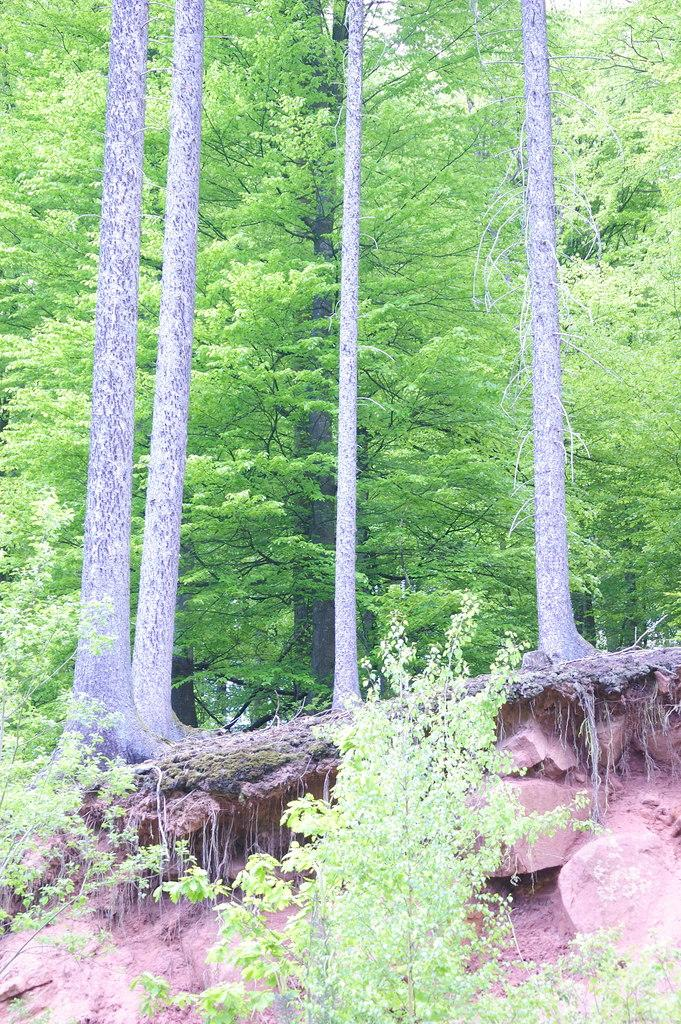What type of vegetation can be seen in the image? There are trees in the image. How many tree trunks are visible in the image? There are trunks of four trees in the image. What type of house can be seen in the image? There is no house present in the image; it only features trees. How many balls are visible in the image? There are no balls present in the image. 